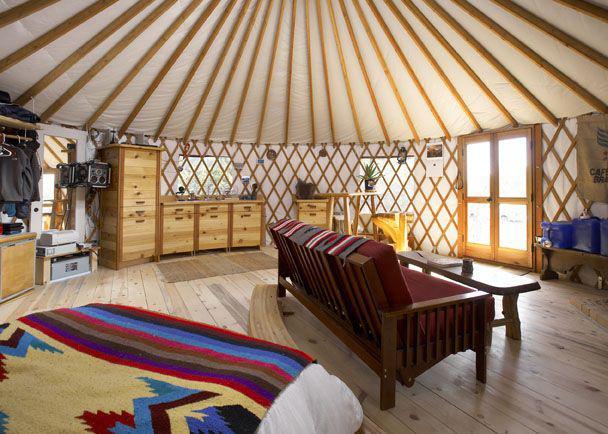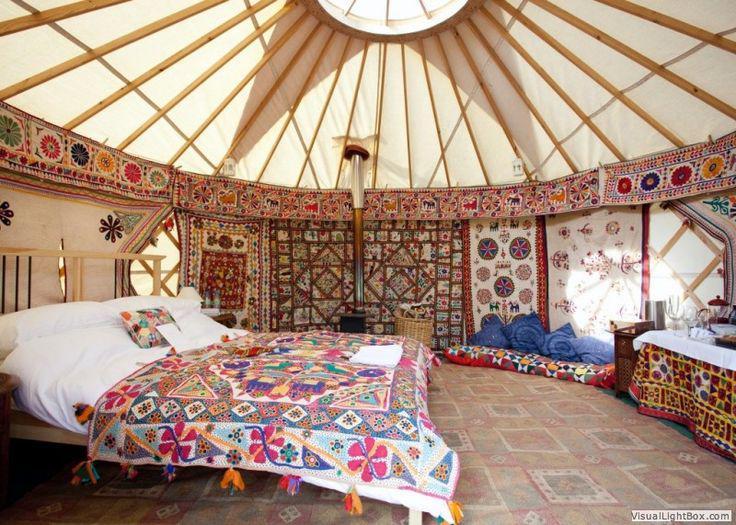The first image is the image on the left, the second image is the image on the right. Analyze the images presented: Is the assertion "There is a bed in the image on the right." valid? Answer yes or no. Yes. 